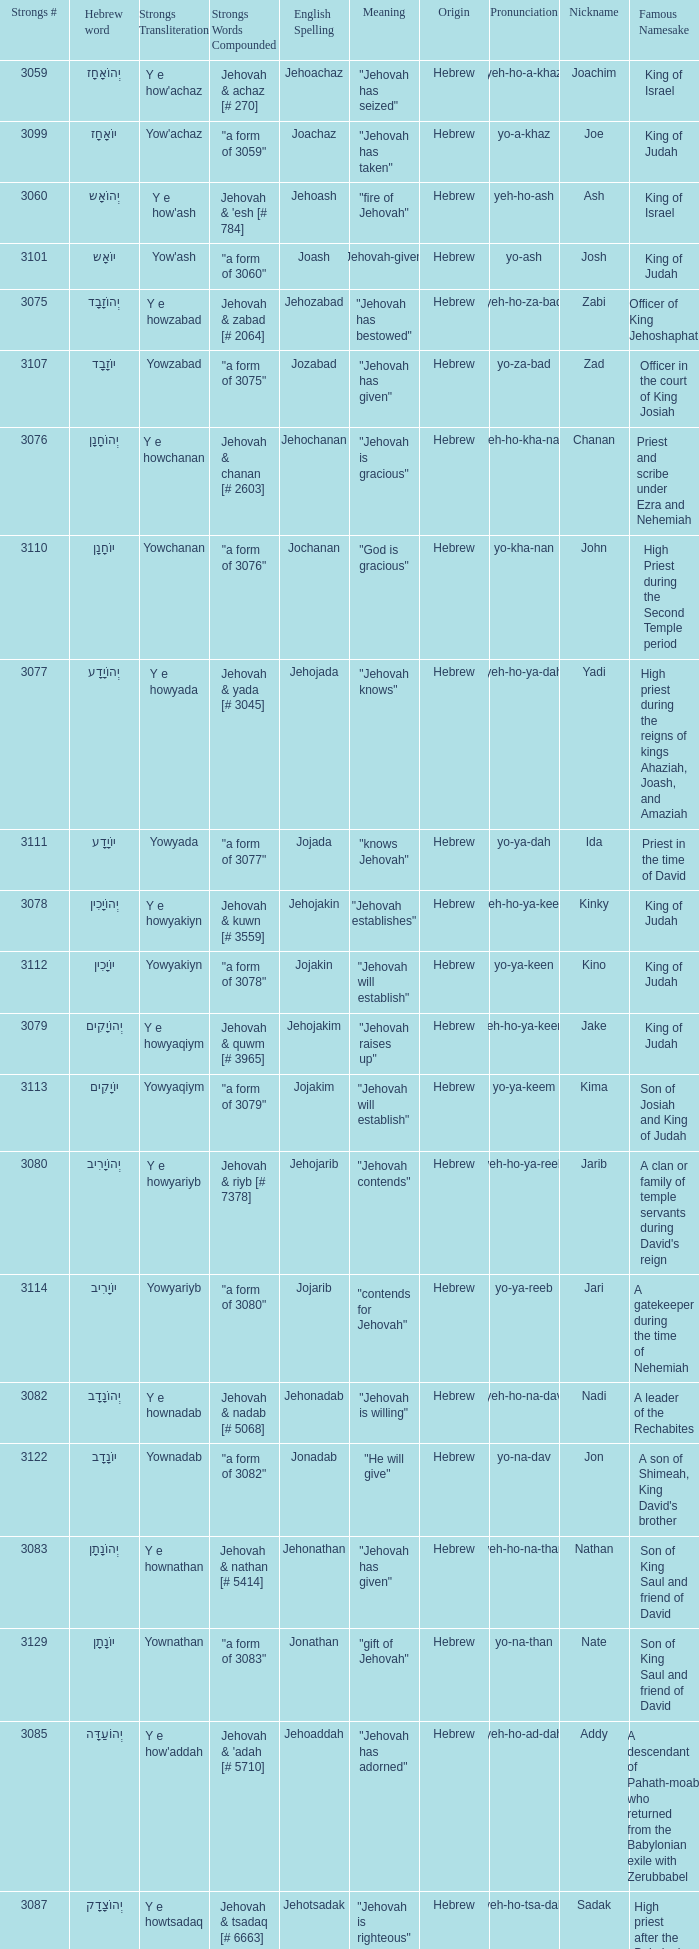What is the strongs words compounded when the english spelling is jonadab? "a form of 3082". 